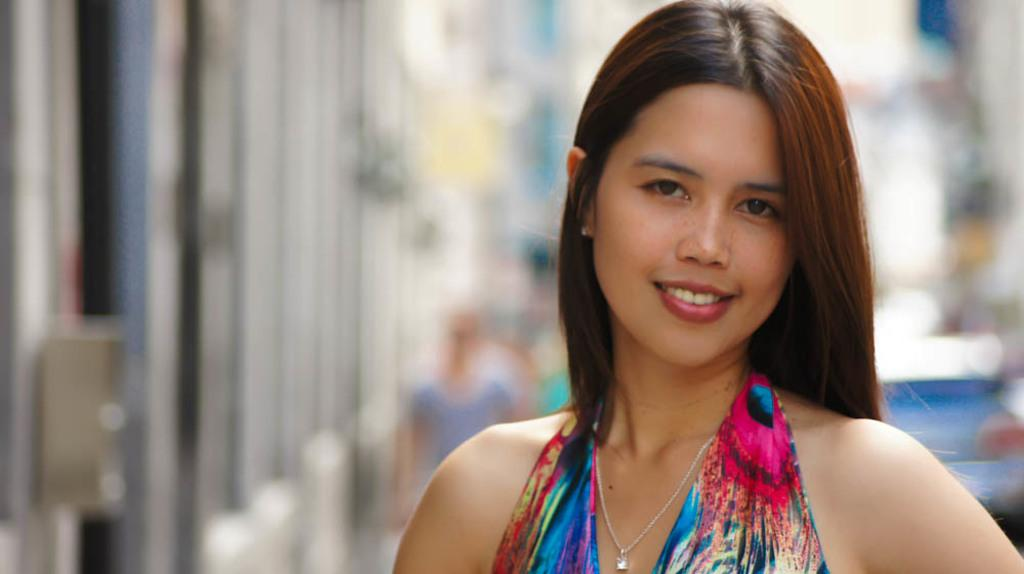What is the woman in the image doing? The woman is standing on the road. What is located behind the woman? There is a car behind the woman. What is situated beside the woman? There is a building beside the woman. What is the woman arguing about with the plane in the image? There is no plane present in the image, and therefore no argument can be observed. 